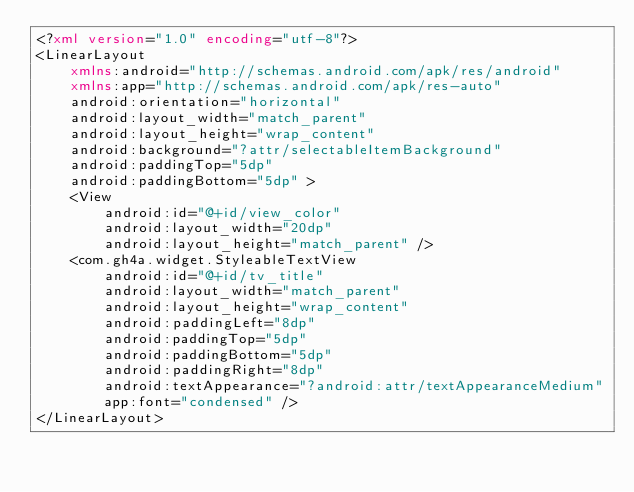Convert code to text. <code><loc_0><loc_0><loc_500><loc_500><_XML_><?xml version="1.0" encoding="utf-8"?>
<LinearLayout
    xmlns:android="http://schemas.android.com/apk/res/android"
    xmlns:app="http://schemas.android.com/apk/res-auto"
    android:orientation="horizontal"
    android:layout_width="match_parent"
    android:layout_height="wrap_content"
    android:background="?attr/selectableItemBackground"
    android:paddingTop="5dp"
    android:paddingBottom="5dp" >
    <View
        android:id="@+id/view_color"
        android:layout_width="20dp"
        android:layout_height="match_parent" />
    <com.gh4a.widget.StyleableTextView
        android:id="@+id/tv_title"
        android:layout_width="match_parent"
        android:layout_height="wrap_content"
        android:paddingLeft="8dp"
        android:paddingTop="5dp"
        android:paddingBottom="5dp"
        android:paddingRight="8dp"
        android:textAppearance="?android:attr/textAppearanceMedium"
        app:font="condensed" />
</LinearLayout>
</code> 